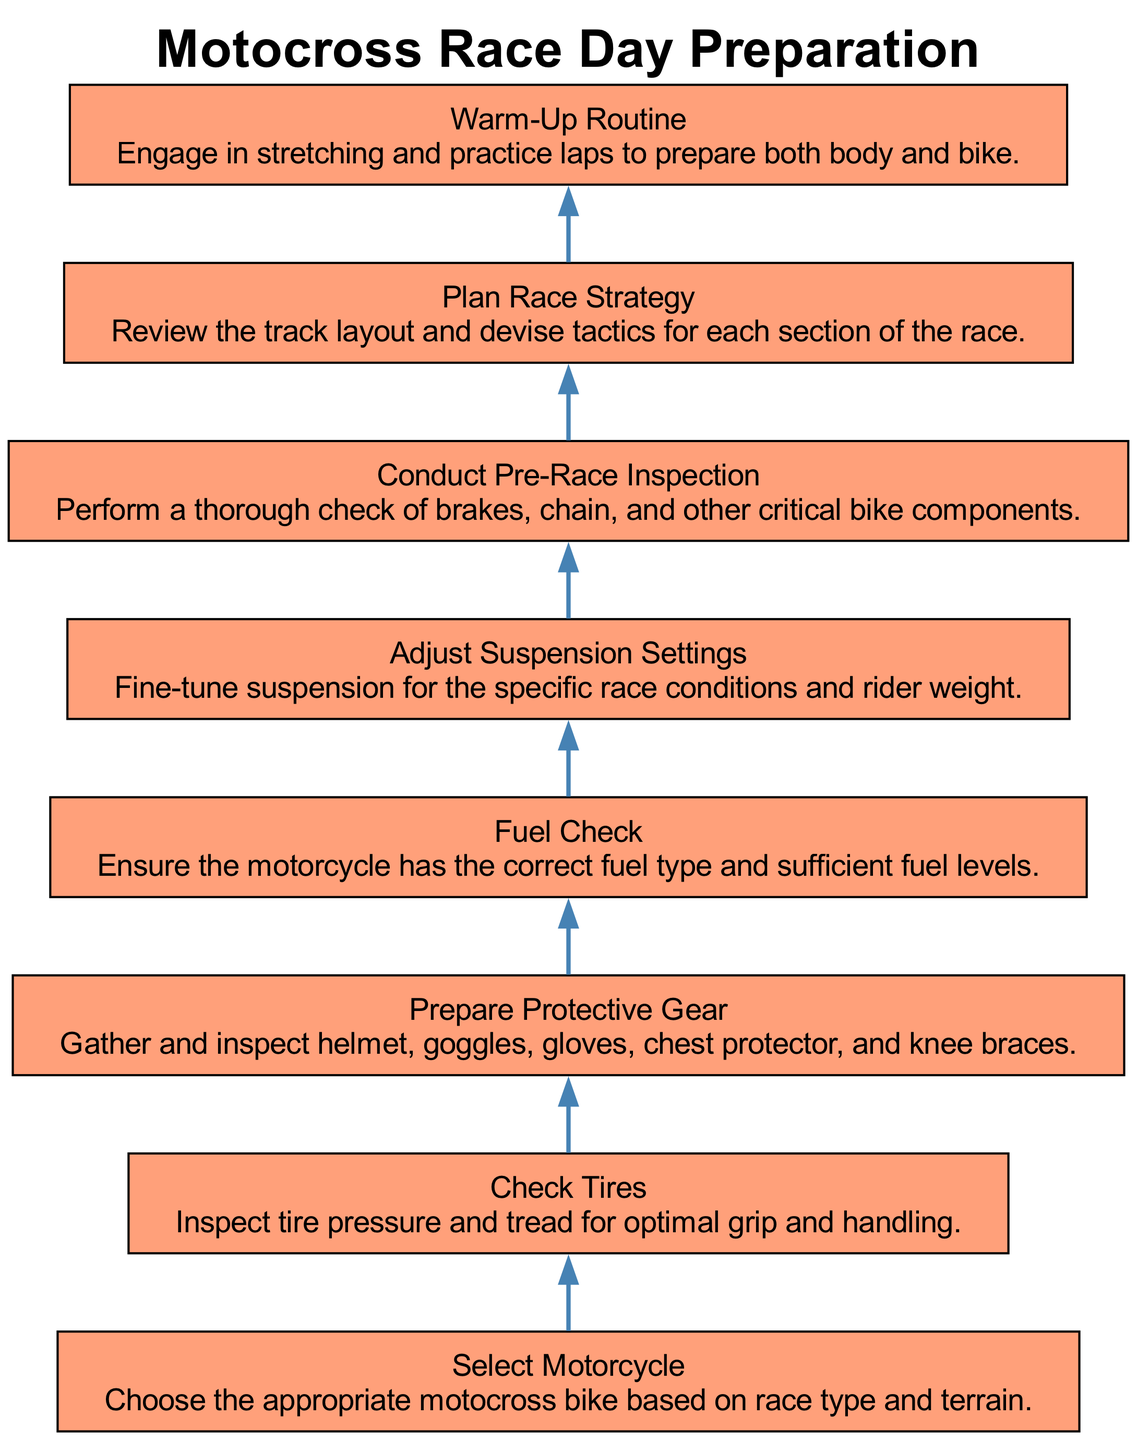What is the first step in the preparation? The first step in the preparation, as indicated at the bottom of the flow chart, is "Select Motorcycle."
Answer: Select Motorcycle How many preparation steps are listed in the diagram? Counting all steps mentioned in the diagram, there are eight distinct nodes, each representing a preparation step.
Answer: Eight Which step comes after "Check Tires"? Following the "Check Tires" node, the next step is "Prepare Protective Gear" as per the flow of the diagram.
Answer: Prepare Protective Gear What is the last step before "Warm-Up Routine"? The last step before "Warm-Up Routine" is "Plan Race Strategy," which precedes warming up in the sequence laid out in the diagram.
Answer: Plan Race Strategy What is the main purpose of the "Conduct Pre-Race Inspection" step? The "Conduct Pre-Race Inspection" step aims to ensure the motorcycle is safe and ready, focusing on vital components such as brakes and the chain.
Answer: Safety check Which steps involve gear or equipment? The "Prepare Protective Gear" and "Adjust Suspension Settings" steps involve preparing gear or equipment for the motocross race.
Answer: Prepare Protective Gear, Adjust Suspension Settings What type of inspection is conducted in the sixth step? The term used in the diagram for the sixth step is "Pre-Race Inspection," which signifies a thorough examination of the motorcycle's critical components.
Answer: Pre-Race Inspection Which step is specifically concerned with fuel requirements? The "Fuel Check" step is dedicated to verifying that the motorcycle has the correct fuel type and enough fuel levels for the race.
Answer: Fuel Check What action is taken immediately after selecting the motorcycle? After selecting the motorcycle, the next action taken is to "Check Tires," ensuring proper pressure and tread for the race.
Answer: Check Tires 